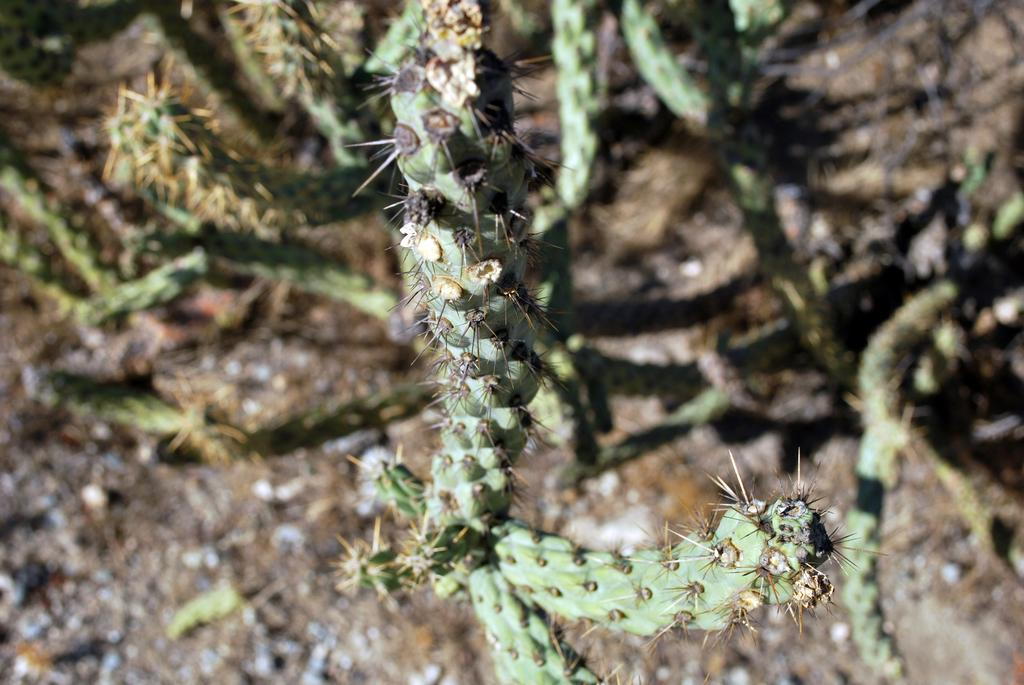What type of plants are in the image? There are cactus plants in the image. What type of bun is being used to hold up the veil in the image? There is no bun or veil present in the image; it features cactus plants. 